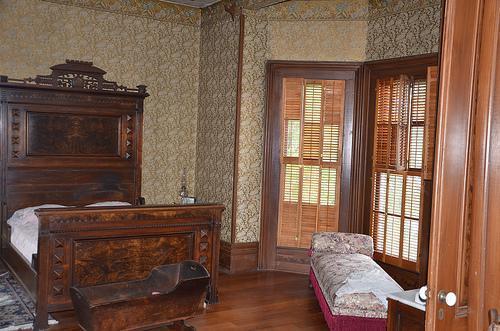How many windows are shown in the picture?
Give a very brief answer. 2. 